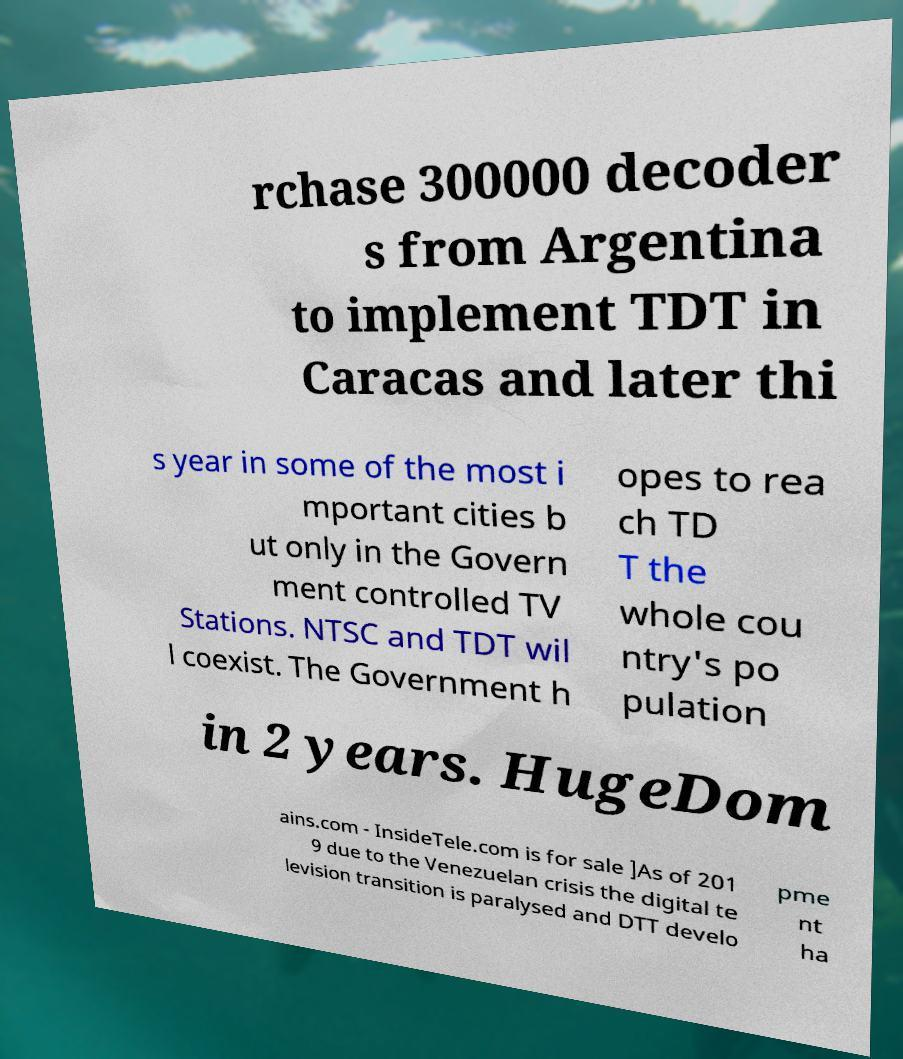Could you assist in decoding the text presented in this image and type it out clearly? rchase 300000 decoder s from Argentina to implement TDT in Caracas and later thi s year in some of the most i mportant cities b ut only in the Govern ment controlled TV Stations. NTSC and TDT wil l coexist. The Government h opes to rea ch TD T the whole cou ntry's po pulation in 2 years. HugeDom ains.com - InsideTele.com is for sale ]As of 201 9 due to the Venezuelan crisis the digital te levision transition is paralysed and DTT develo pme nt ha 